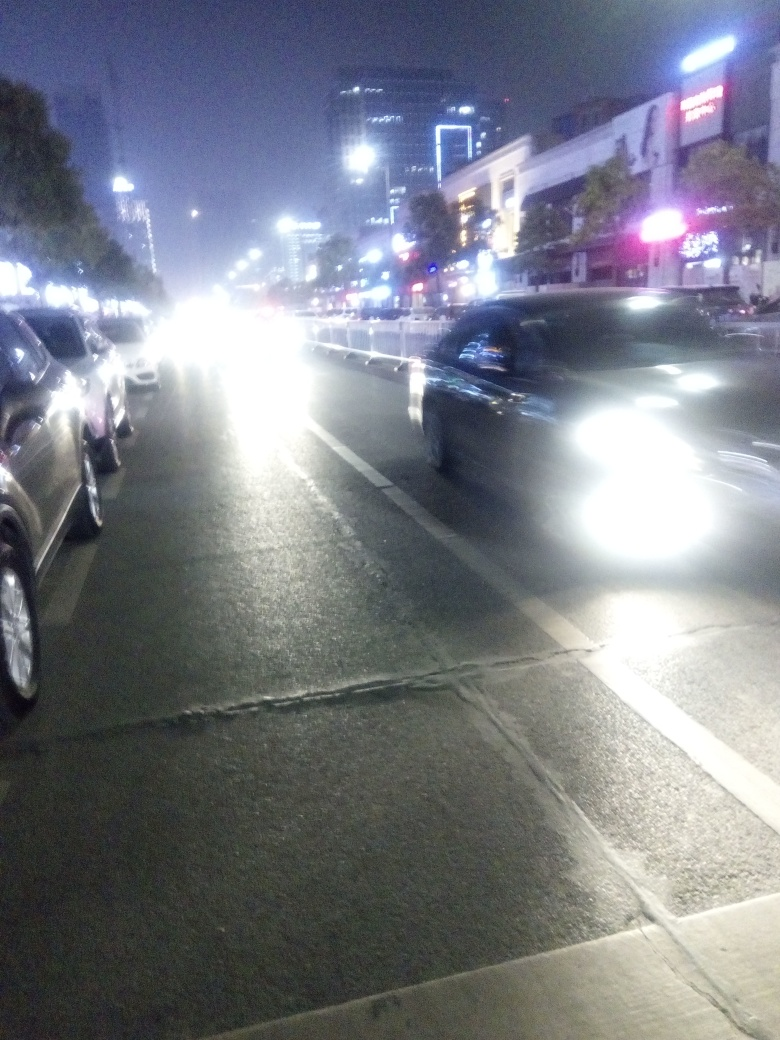What can you infer about the location from the architectural styles and signage visible? The architecture comprises modern buildings with commercial signage, hinting at an urban setting possibly in a downtown area. The presence of billboards and neon signs suggest a place that is commercially active, likely a city center with an active nightlife. 